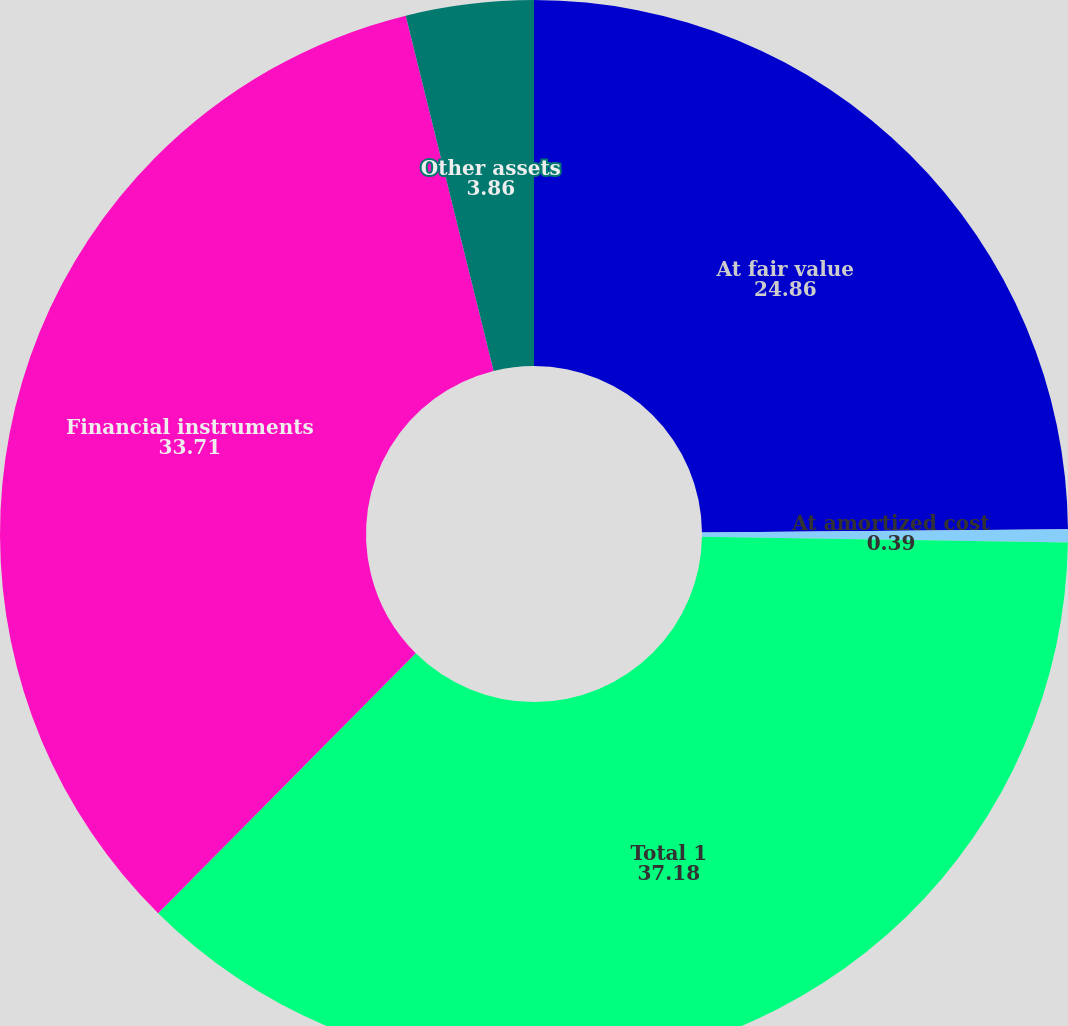Convert chart. <chart><loc_0><loc_0><loc_500><loc_500><pie_chart><fcel>At fair value<fcel>At amortized cost<fcel>Total 1<fcel>Financial instruments<fcel>Other assets<nl><fcel>24.86%<fcel>0.39%<fcel>37.18%<fcel>33.71%<fcel>3.86%<nl></chart> 